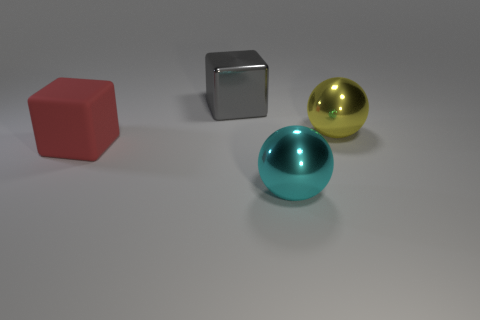Add 2 small cyan matte objects. How many objects exist? 6 Subtract all big purple rubber things. Subtract all large spheres. How many objects are left? 2 Add 4 large yellow things. How many large yellow things are left? 5 Add 2 big red blocks. How many big red blocks exist? 3 Subtract 0 brown spheres. How many objects are left? 4 